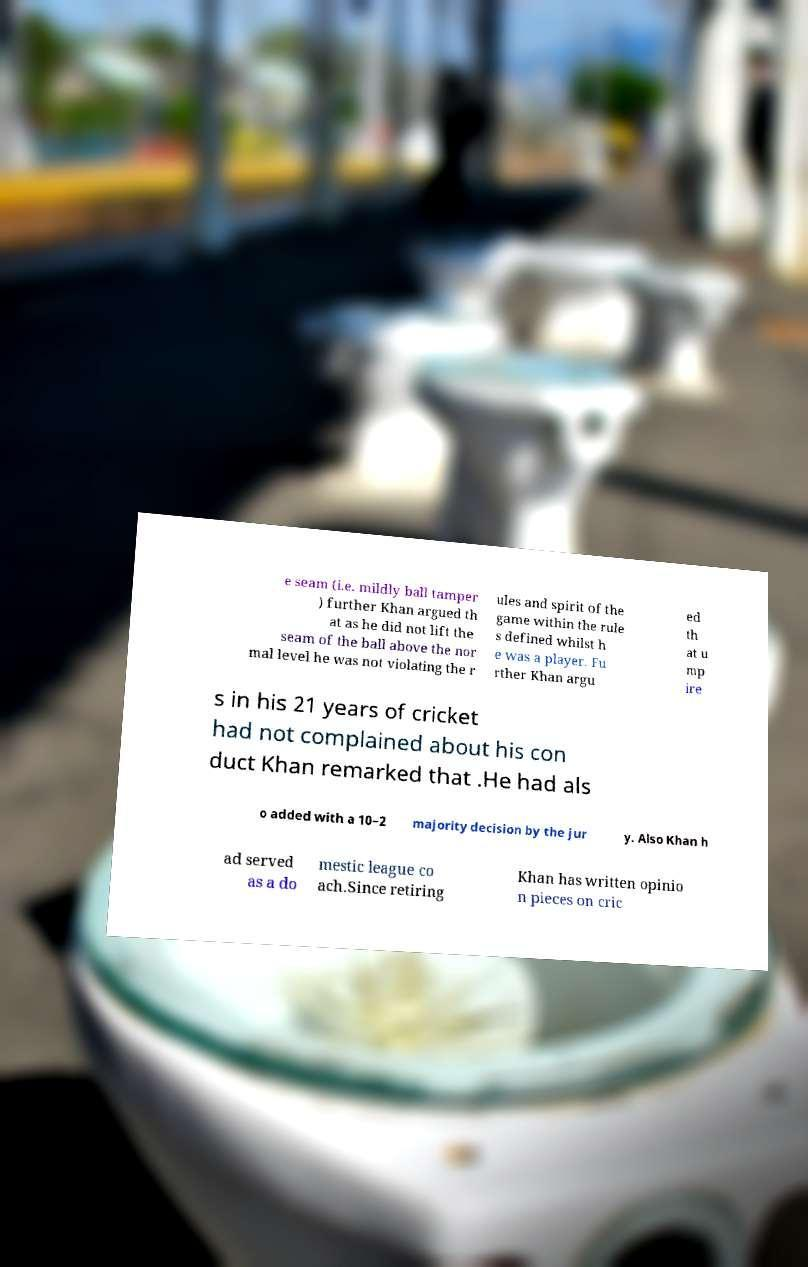Could you extract and type out the text from this image? e seam (i.e. mildly ball tamper ) further Khan argued th at as he did not lift the seam of the ball above the nor mal level he was not violating the r ules and spirit of the game within the rule s defined whilst h e was a player. Fu rther Khan argu ed th at u mp ire s in his 21 years of cricket had not complained about his con duct Khan remarked that .He had als o added with a 10–2 majority decision by the jur y. Also Khan h ad served as a do mestic league co ach.Since retiring Khan has written opinio n pieces on cric 